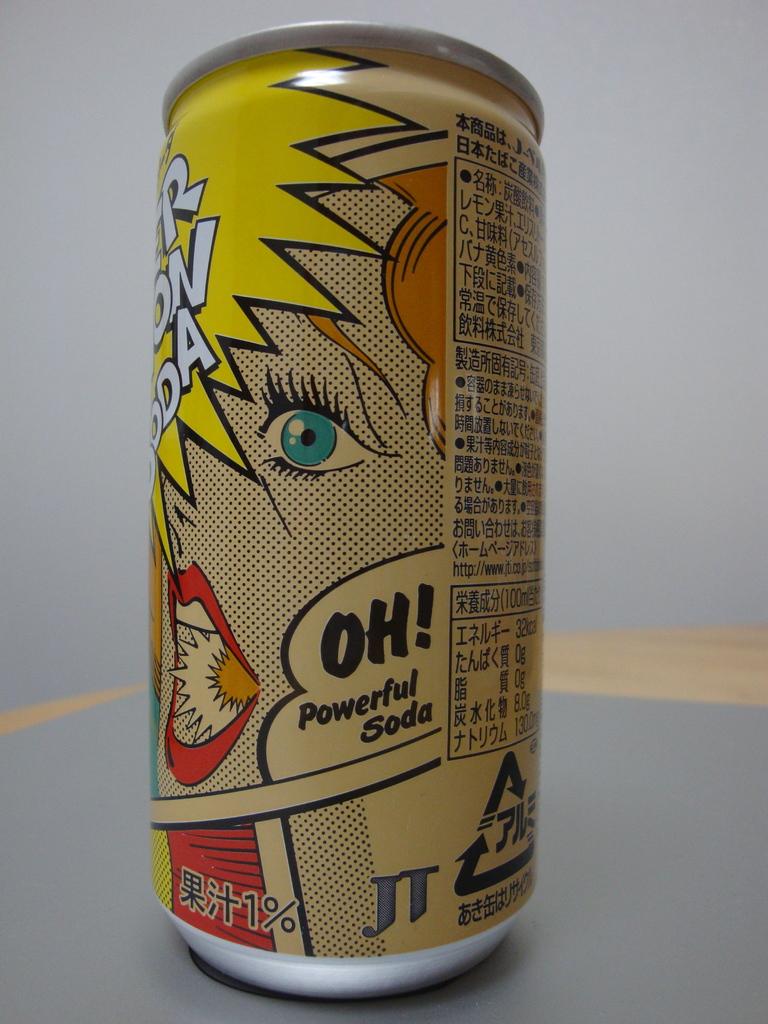What word is printed with an exclamation point?
Your answer should be very brief. Oh. 